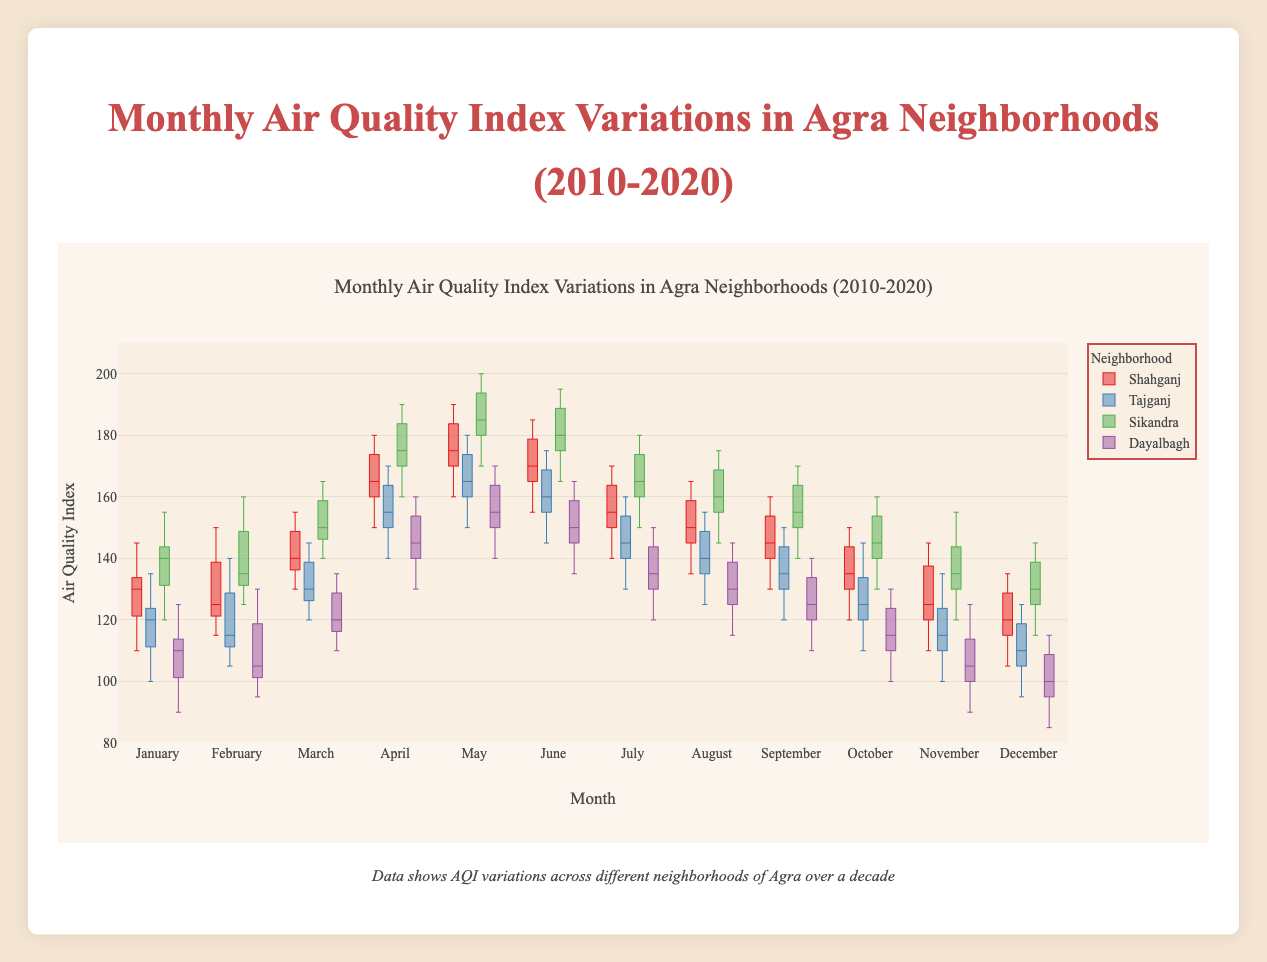Which neighborhood has the highest median AQI in May? By reviewing the box plot, we look for the neighborhood with the tallest box in May. Sikandra's box plot is higher than the others indicating a higher median AQI.
Answer: Sikandra Which months show the highest AQI variability in Shahganj? Variability can be identified by the interquartile range (IQR) of the box plot. Shahganj exhibits highest variability in April and May because their boxes are tallest.
Answer: April, May Compare the median AQI of Dayalbagh in January and June. Which is higher? By comparing the horizontal lines within the boxes for January and June in Dayalbagh, the median for June is higher.
Answer: June In Shahganj, which month has the lowest minimum AQI recorded? The minimum value can be seen by looking at the lowest point of the whiskers. December has the lowest point for Shahganj.
Answer: December Is there any month in Dayalbagh where the AQI does not show any outliers? By examining the points outside the whiskers (outliers), September in Dayalbagh does not have outliers.
Answer: September During which months is the AQI in Tajganj consistently below 135? Refer to the boxes of Tajganj. If the upper whisker is below 135, then all data points are less than 135. January, February, October, November and December meet this criterion.
Answer: January, February, October, November, December What is the median AQI of Sikandra in March? The median value is represented by the line inside the box. In March, Sikandra's median AQI is around 155.
Answer: 155 Which neighborhood shows the most stable AQI throughout the year? Stability can be deduced by smaller IQR (box height) across all months. Dayalbagh has the most consistent IQRs throughout the months.
Answer: Dayalbagh Between Shahganj and Tajganj, which has a higher maximum AQI in June? Check the upper limit of the whiskers in June. Shahganj has a higher maximum AQI than Tajganj.
Answer: Shahganj 